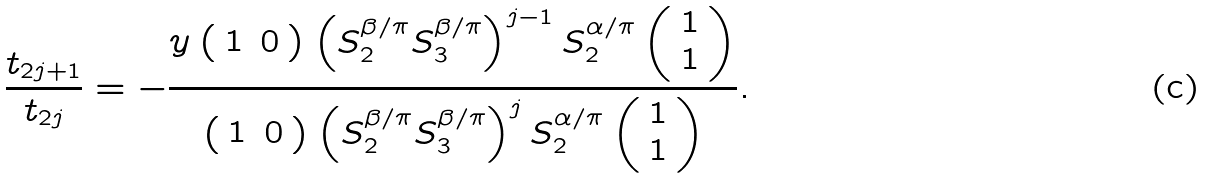<formula> <loc_0><loc_0><loc_500><loc_500>\frac { t _ { 2 j + 1 } } { t _ { 2 j } } = - \frac { y \left ( \begin{array} { c c } 1 & 0 \end{array} \right ) \left ( S _ { 2 } ^ { \beta / \pi } S _ { 3 } ^ { \beta / \pi } \right ) ^ { j - 1 } S _ { 2 } ^ { \alpha / \pi } \left ( \begin{array} { c } 1 \\ 1 \end{array} \right ) } { \left ( \begin{array} { c c } 1 & 0 \end{array} \right ) \left ( S _ { 2 } ^ { \beta / \pi } S _ { 3 } ^ { \beta / \pi } \right ) ^ { j } S _ { 2 } ^ { \alpha / \pi } \left ( \begin{array} { c } 1 \\ 1 \end{array} \right ) } .</formula> 